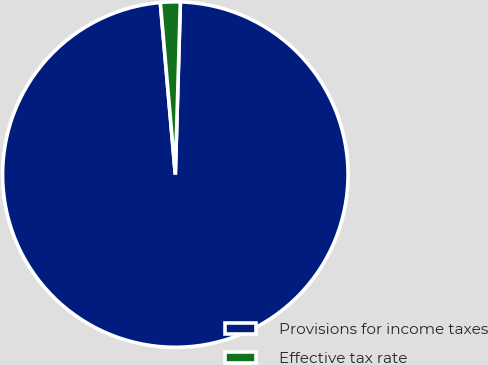Convert chart. <chart><loc_0><loc_0><loc_500><loc_500><pie_chart><fcel>Provisions for income taxes<fcel>Effective tax rate<nl><fcel>98.15%<fcel>1.85%<nl></chart> 